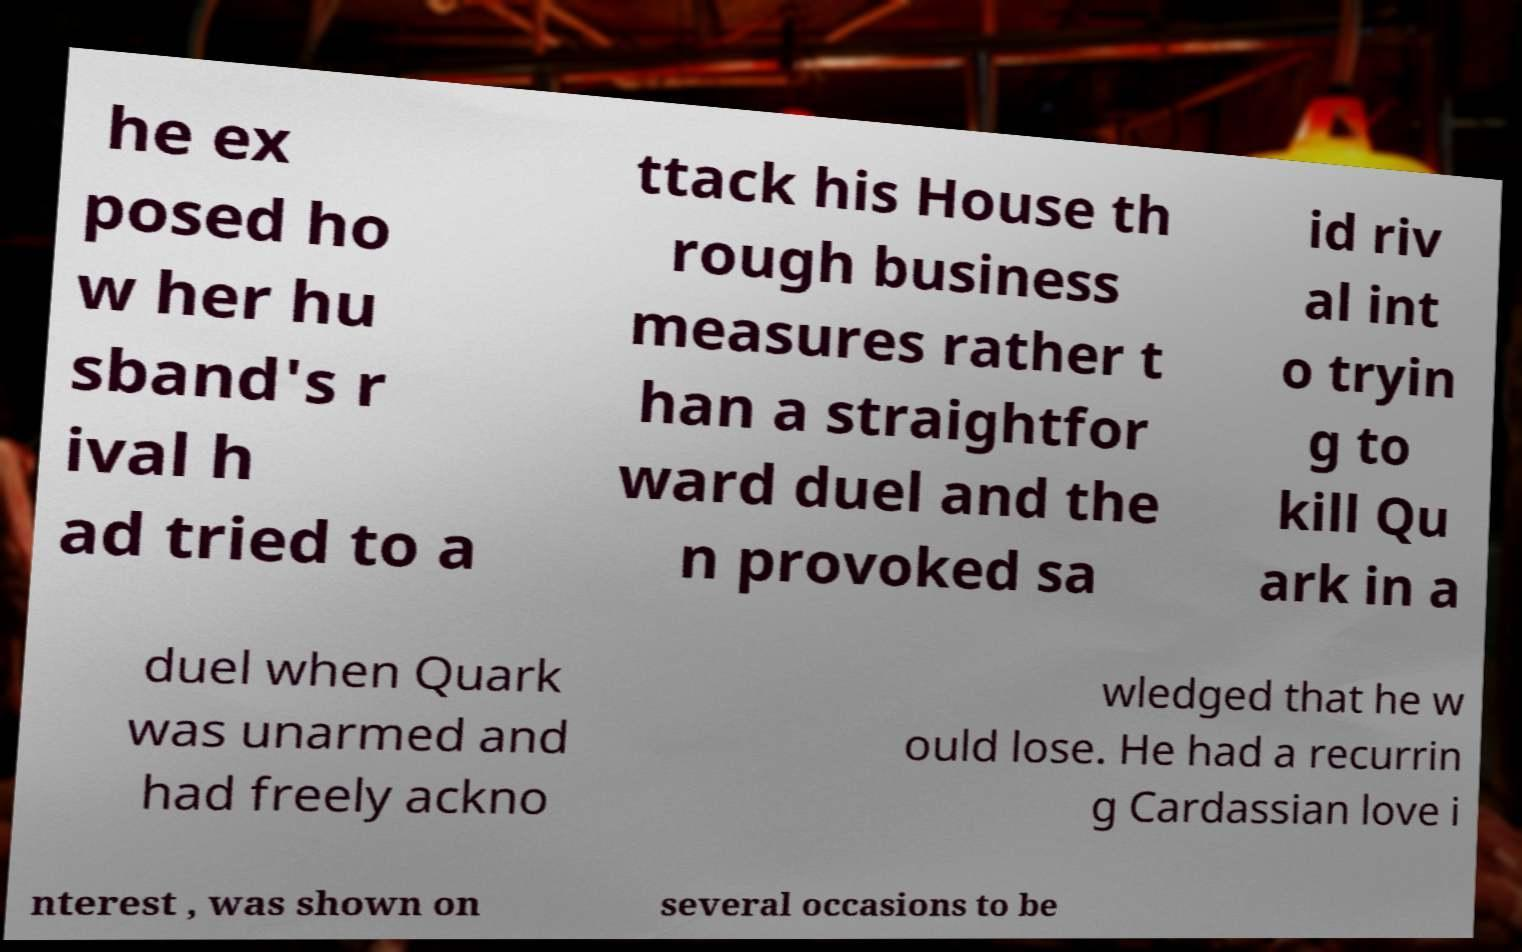Can you read and provide the text displayed in the image?This photo seems to have some interesting text. Can you extract and type it out for me? he ex posed ho w her hu sband's r ival h ad tried to a ttack his House th rough business measures rather t han a straightfor ward duel and the n provoked sa id riv al int o tryin g to kill Qu ark in a duel when Quark was unarmed and had freely ackno wledged that he w ould lose. He had a recurrin g Cardassian love i nterest , was shown on several occasions to be 